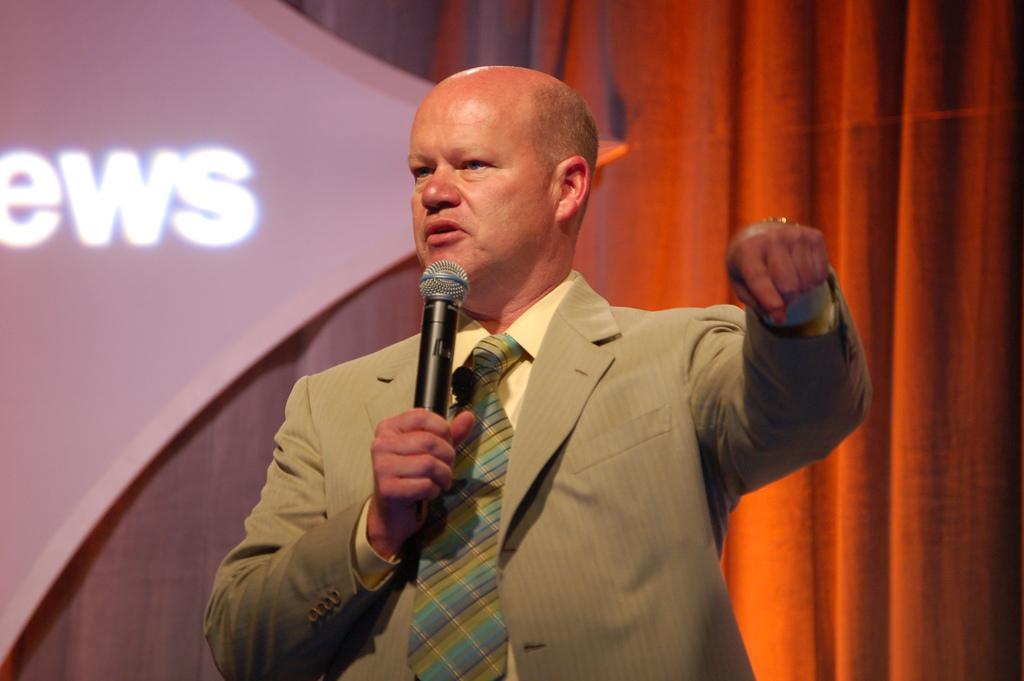Can you describe this image briefly? This is the picture of a man in brown blazer was holding a microphone and explaining something. Behind the man there is a curtain and a board. 